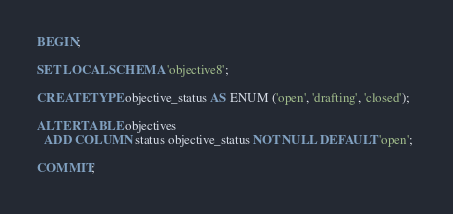<code> <loc_0><loc_0><loc_500><loc_500><_SQL_>BEGIN;

SET LOCAL SCHEMA 'objective8';

CREATE TYPE objective_status AS ENUM ('open', 'drafting', 'closed');

ALTER TABLE objectives
  ADD COLUMN status objective_status NOT NULL DEFAULT 'open'; 

COMMIT;
</code> 